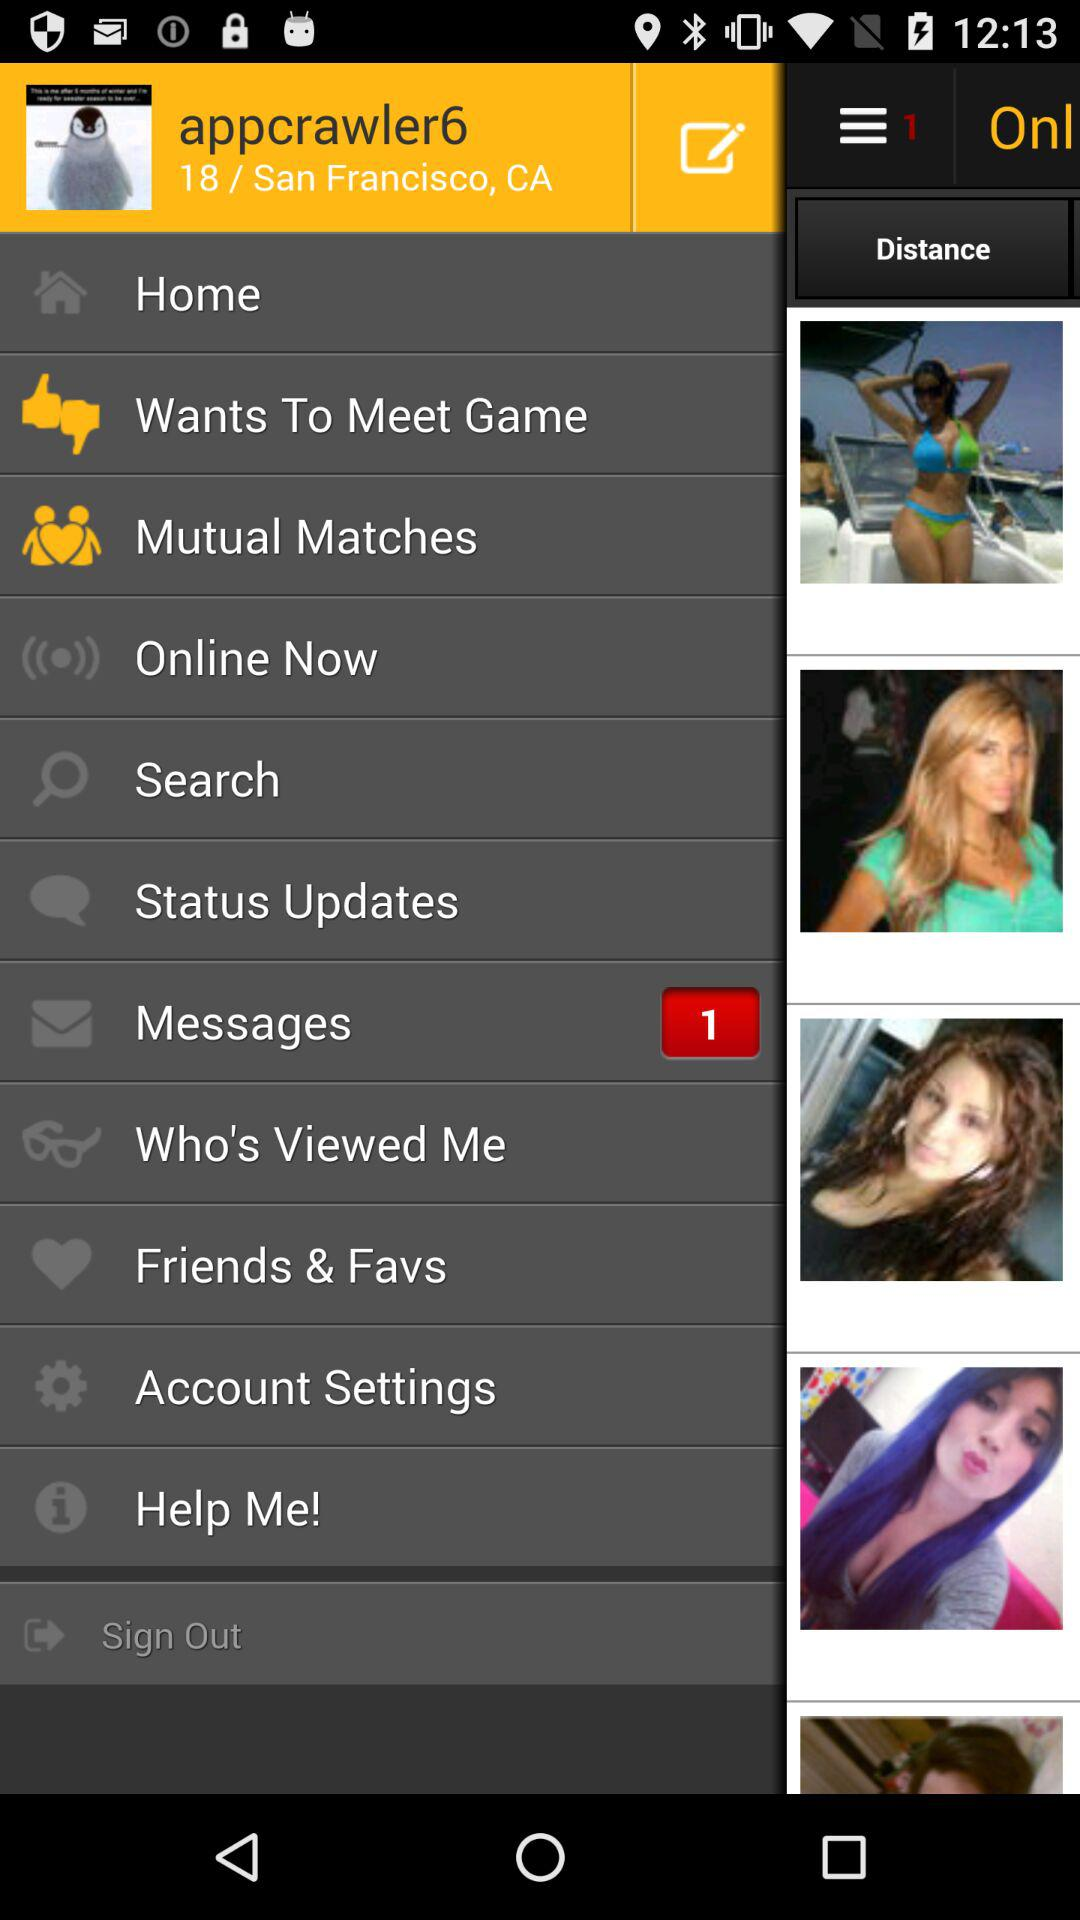What is the given location? The given location is San Francisco, CA. 